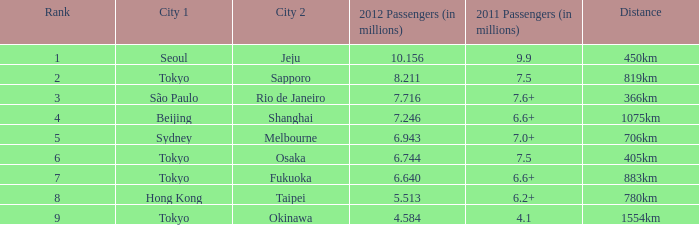6 million passengers? São Paulo. 